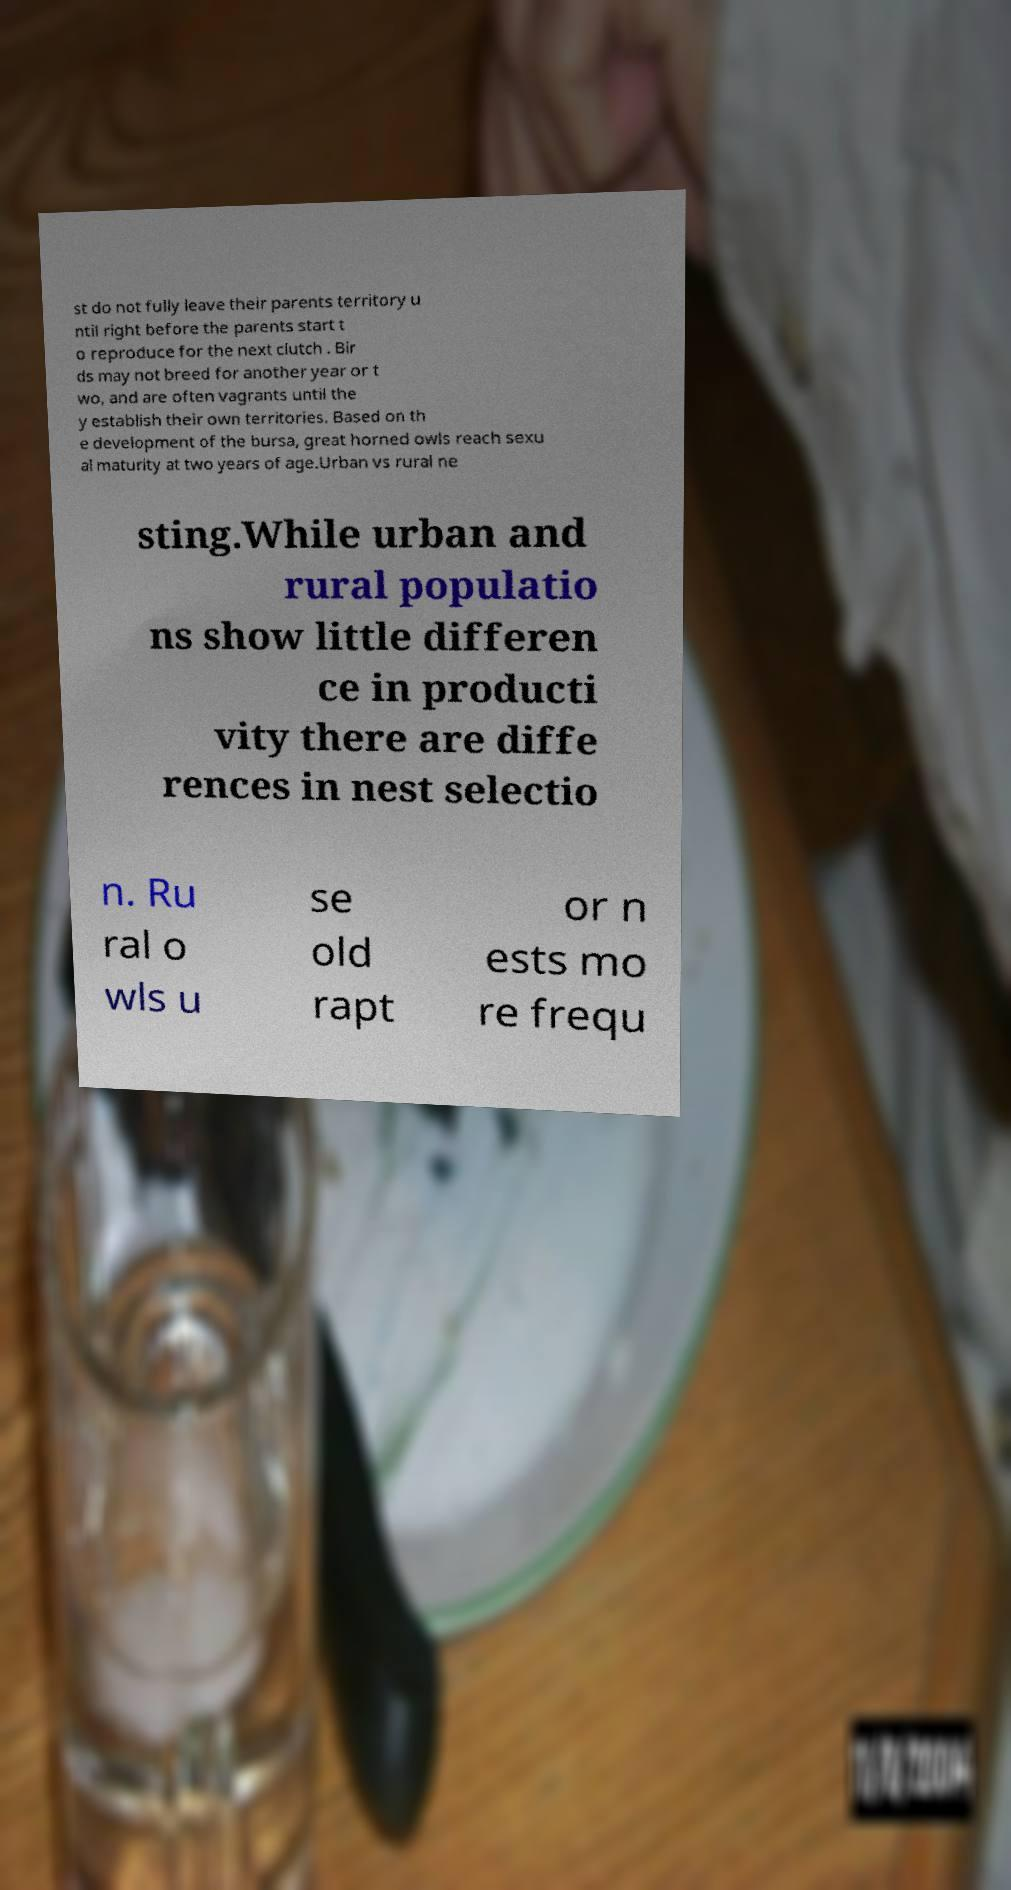I need the written content from this picture converted into text. Can you do that? st do not fully leave their parents territory u ntil right before the parents start t o reproduce for the next clutch . Bir ds may not breed for another year or t wo, and are often vagrants until the y establish their own territories. Based on th e development of the bursa, great horned owls reach sexu al maturity at two years of age.Urban vs rural ne sting.While urban and rural populatio ns show little differen ce in producti vity there are diffe rences in nest selectio n. Ru ral o wls u se old rapt or n ests mo re frequ 